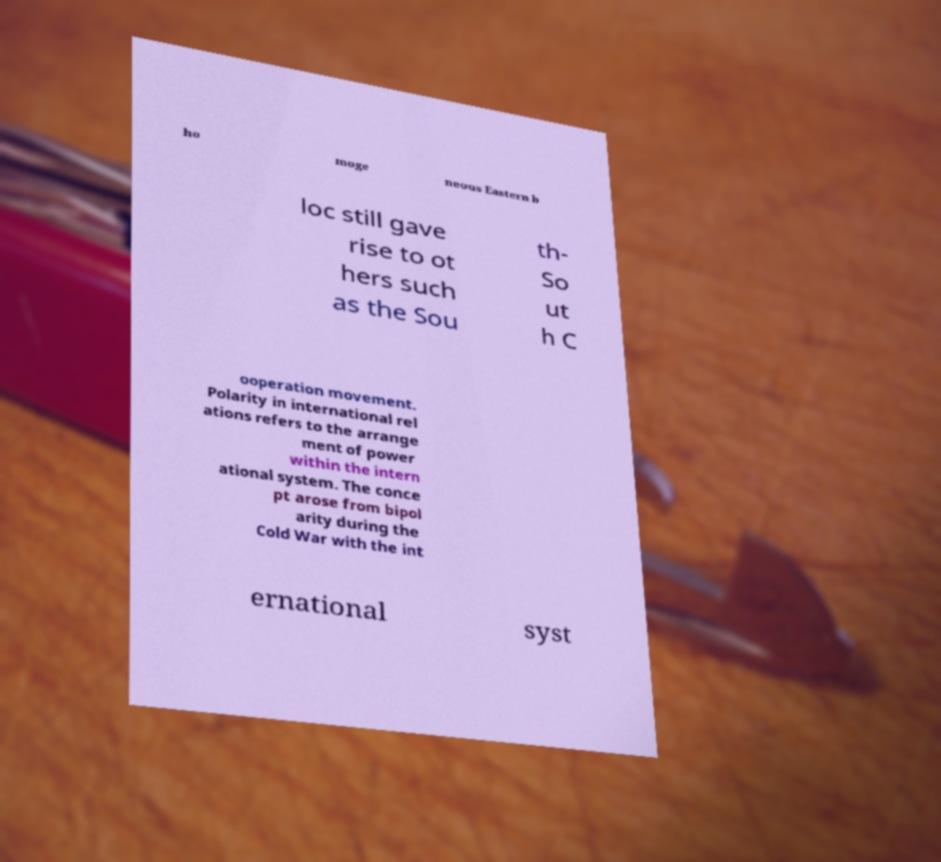For documentation purposes, I need the text within this image transcribed. Could you provide that? ho moge neous Eastern b loc still gave rise to ot hers such as the Sou th- So ut h C ooperation movement. Polarity in international rel ations refers to the arrange ment of power within the intern ational system. The conce pt arose from bipol arity during the Cold War with the int ernational syst 